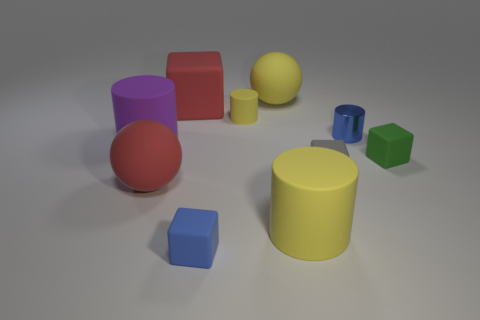Are there any other things that have the same material as the tiny blue cylinder?
Your answer should be compact. No. What size is the blue thing behind the green rubber object?
Offer a terse response. Small. There is a gray object; is it the same size as the blue rubber object on the left side of the tiny yellow matte object?
Keep it short and to the point. Yes. What is the color of the rubber block that is behind the small yellow object that is behind the tiny metal cylinder?
Your answer should be compact. Red. What number of other objects are the same color as the tiny metal cylinder?
Make the answer very short. 1. How big is the blue matte cube?
Provide a succinct answer. Small. Are there more tiny matte cubes behind the blue rubber block than blue shiny things that are behind the small shiny cylinder?
Your answer should be compact. Yes. There is a cylinder that is to the right of the large yellow cylinder; what number of rubber cubes are left of it?
Keep it short and to the point. 3. There is a big red rubber object behind the big purple cylinder; is its shape the same as the tiny gray object?
Offer a very short reply. Yes. What material is the blue object that is the same shape as the small yellow matte thing?
Your response must be concise. Metal. 